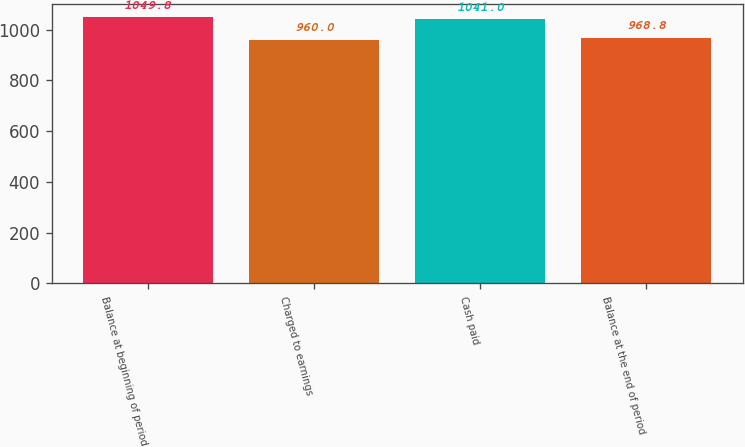Convert chart to OTSL. <chart><loc_0><loc_0><loc_500><loc_500><bar_chart><fcel>Balance at beginning of period<fcel>Charged to earnings<fcel>Cash paid<fcel>Balance at the end of period<nl><fcel>1049.8<fcel>960<fcel>1041<fcel>968.8<nl></chart> 